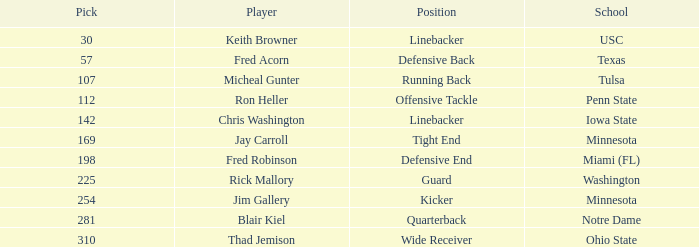What is Thad Jemison's position? Wide Receiver. 